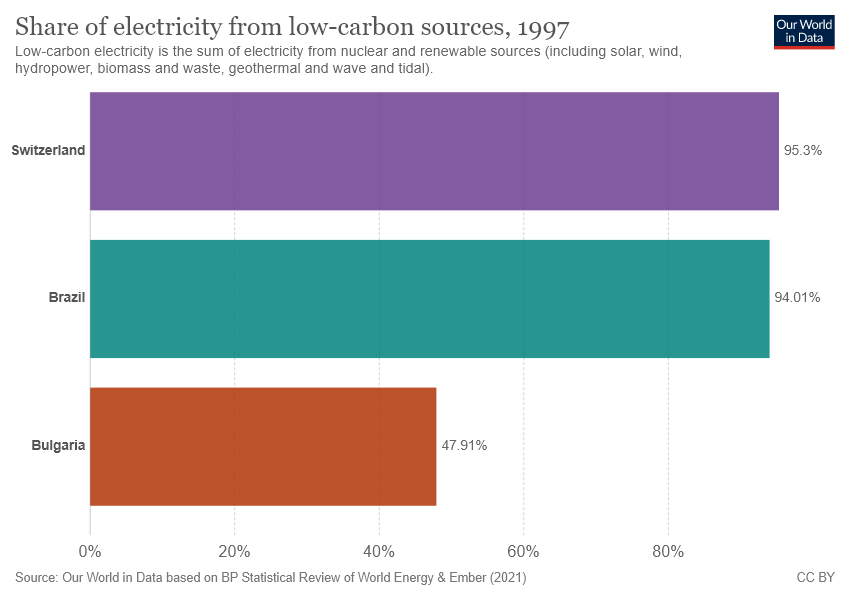Outline some significant characteristics in this image. There are three colors used in the graph. The largest two bars have a difference of 1.29... 